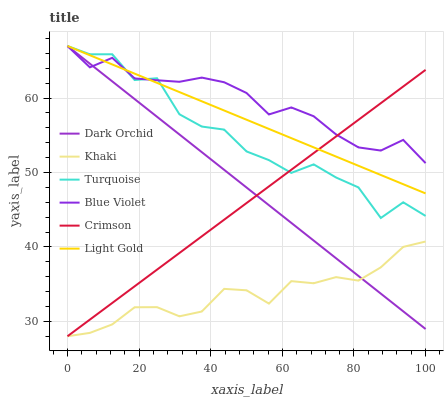Does Dark Orchid have the minimum area under the curve?
Answer yes or no. No. Does Dark Orchid have the maximum area under the curve?
Answer yes or no. No. Is Khaki the smoothest?
Answer yes or no. No. Is Khaki the roughest?
Answer yes or no. No. Does Dark Orchid have the lowest value?
Answer yes or no. No. Does Khaki have the highest value?
Answer yes or no. No. Is Khaki less than Blue Violet?
Answer yes or no. Yes. Is Turquoise greater than Khaki?
Answer yes or no. Yes. Does Khaki intersect Blue Violet?
Answer yes or no. No. 